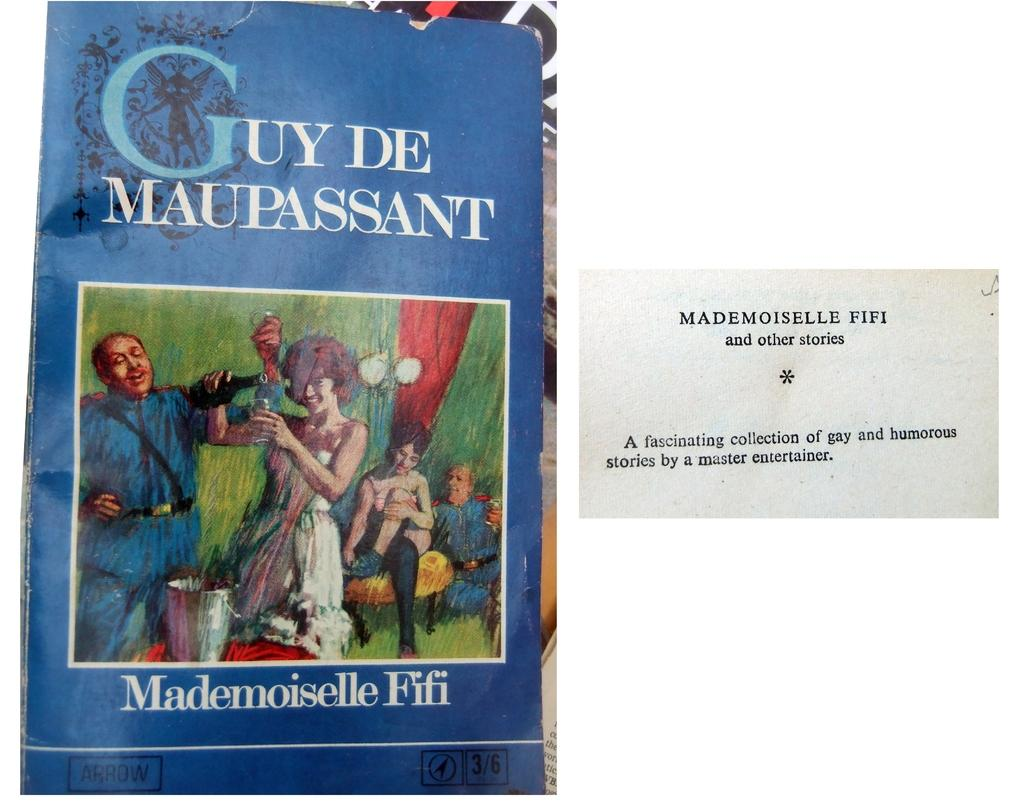Provide a one-sentence caption for the provided image. A blue book cover titled Guy De Maupassant. 